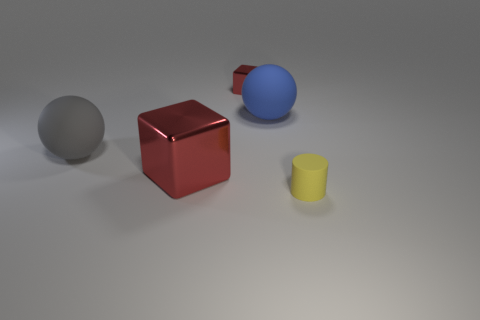Add 3 small yellow matte things. How many objects exist? 8 Subtract all cylinders. How many objects are left? 4 Subtract 0 purple cylinders. How many objects are left? 5 Subtract all gray metallic objects. Subtract all matte things. How many objects are left? 2 Add 4 small red metallic things. How many small red metallic things are left? 5 Add 2 large rubber things. How many large rubber things exist? 4 